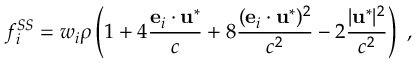<formula> <loc_0><loc_0><loc_500><loc_500>f _ { i } ^ { S S } = w _ { i } \rho \left ( 1 + 4 \frac { { e } _ { i } \cdot u ^ { * } } { c } + 8 \frac { ( { e } _ { i } \cdot u ^ { * } ) ^ { 2 } } { c ^ { 2 } } - 2 \frac { | u ^ { * } | ^ { 2 } } { c ^ { 2 } } \right ) \ ,</formula> 